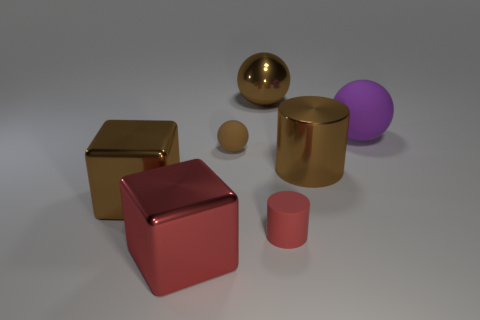Subtract all brown balls. How many balls are left? 1 Add 1 tiny matte objects. How many objects exist? 8 Subtract all balls. How many objects are left? 4 Add 4 purple matte balls. How many purple matte balls exist? 5 Subtract 0 gray cylinders. How many objects are left? 7 Subtract all small brown matte objects. Subtract all large brown shiny spheres. How many objects are left? 5 Add 1 big purple balls. How many big purple balls are left? 2 